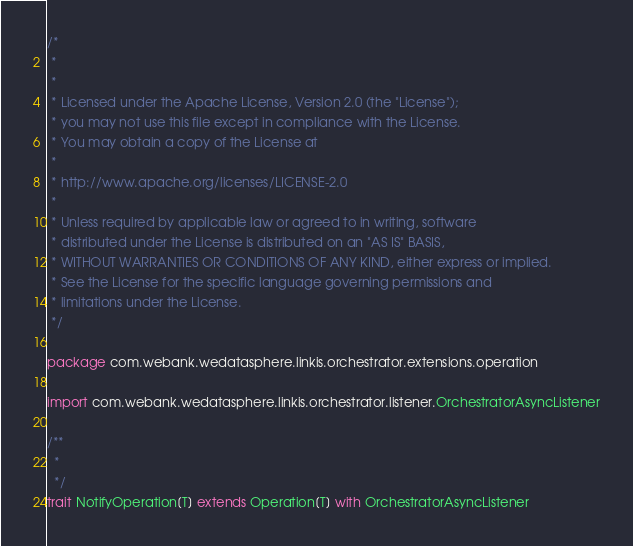<code> <loc_0><loc_0><loc_500><loc_500><_Scala_>/*
 *
 *
 * Licensed under the Apache License, Version 2.0 (the "License");
 * you may not use this file except in compliance with the License.
 * You may obtain a copy of the License at
 *
 * http://www.apache.org/licenses/LICENSE-2.0
 *
 * Unless required by applicable law or agreed to in writing, software
 * distributed under the License is distributed on an "AS IS" BASIS,
 * WITHOUT WARRANTIES OR CONDITIONS OF ANY KIND, either express or implied.
 * See the License for the specific language governing permissions and
 * limitations under the License.
 */

package com.webank.wedatasphere.linkis.orchestrator.extensions.operation

import com.webank.wedatasphere.linkis.orchestrator.listener.OrchestratorAsyncListener

/**
  *
  */
trait NotifyOperation[T] extends Operation[T] with OrchestratorAsyncListener</code> 